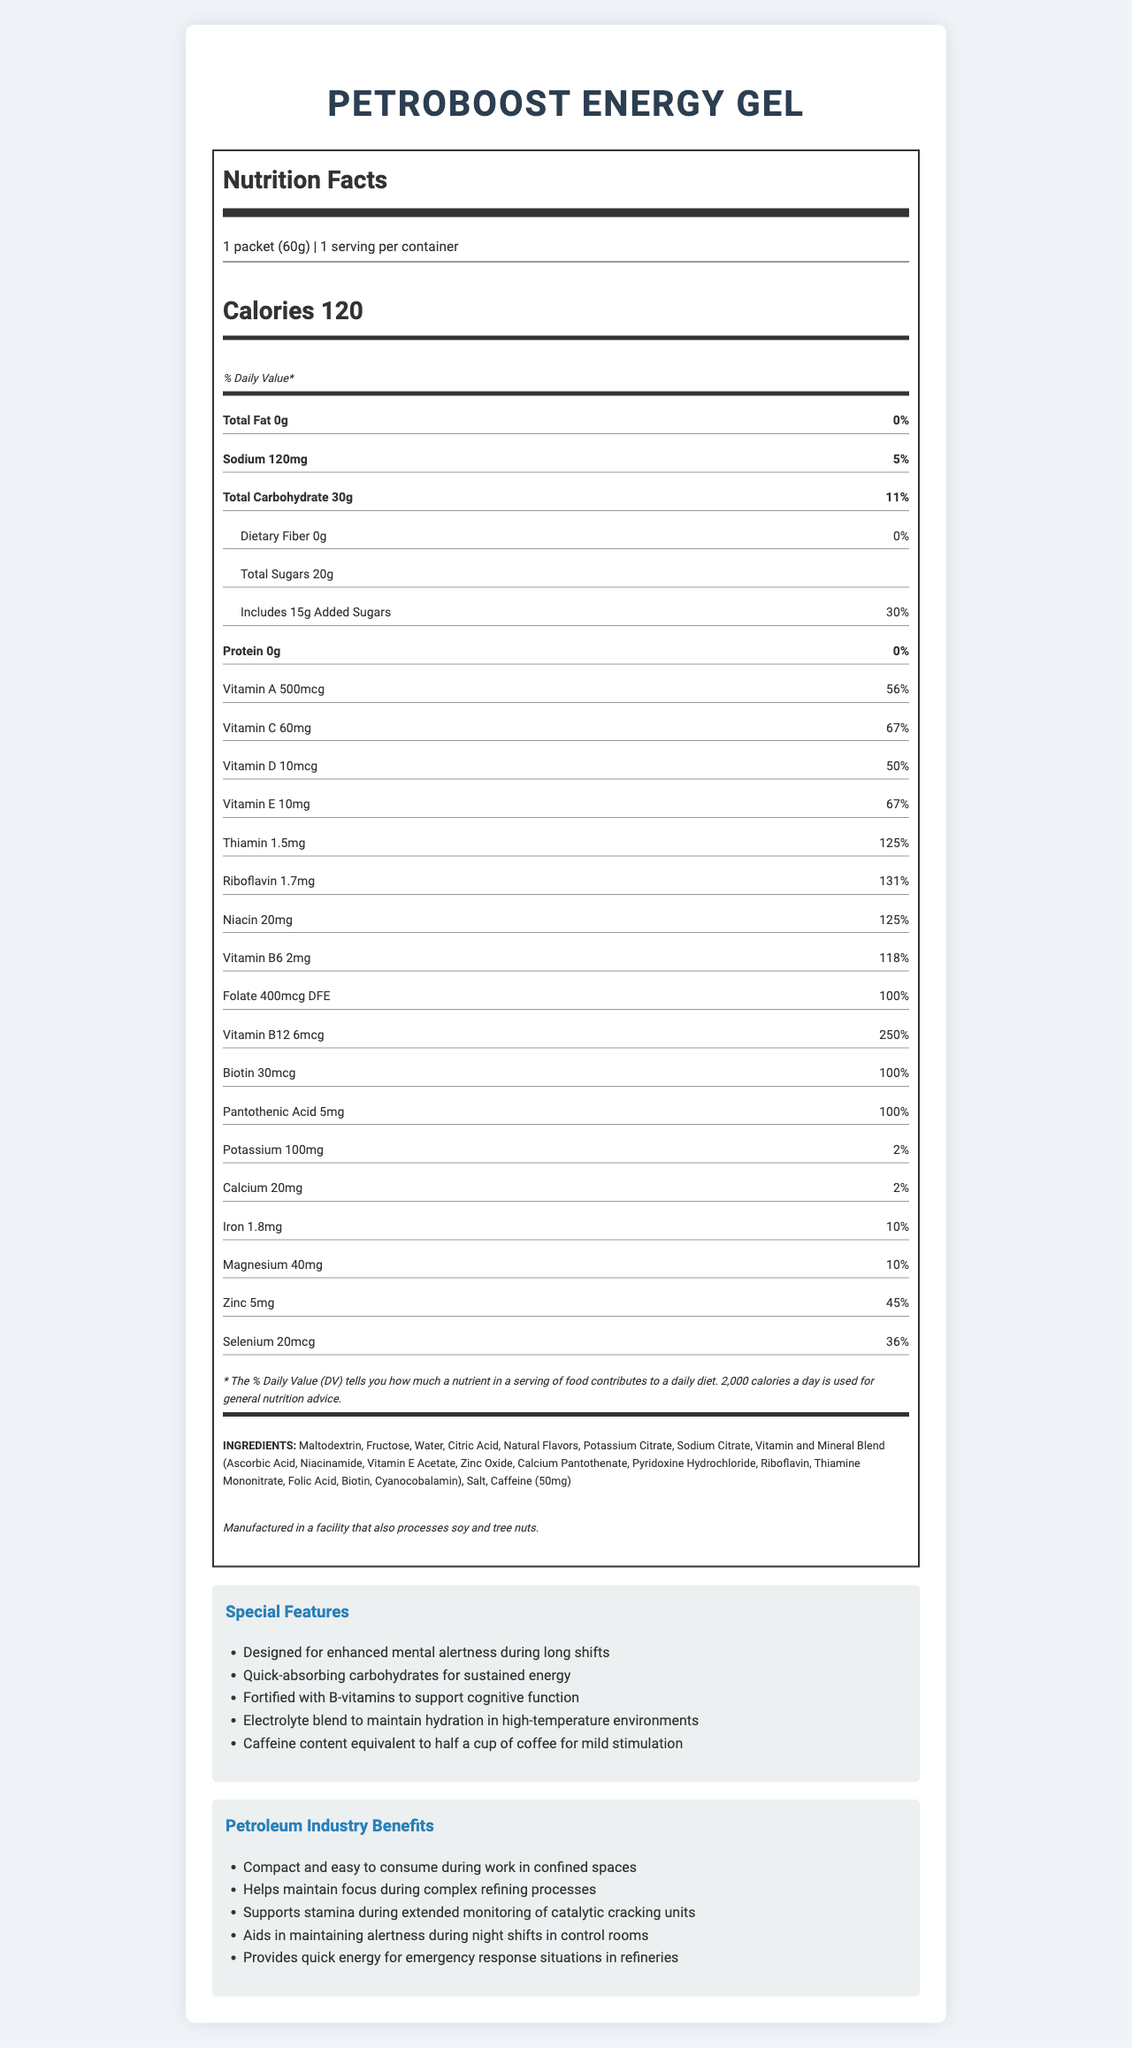what is the serving size of the PetroBoost Energy Gel? The serving size is listed at the top of the nutrition facts label as "1 packet (60g)".
Answer: 1 packet (60g) how many calories are in one serving of the PetroBoost Energy Gel? The number of calories per serving is prominently displayed in the nutrition facts section.
Answer: 120 how much sodium is in one packet? The sodium content is shown in the nutrition facts label with the amount being 120mg and a percent daily value of 5%.
Answer: 120mg which vitamin has the highest percent daily value in this product? A. Vitamin A B. Vitamin C C. Vitamin B12 D. Vitamin E Vitamin B12 has a percent daily value of 250%, which is higher than the percent daily values of other vitamins listed in the nutrition label.
Answer: C. Vitamin B12 is the PetroBoost Energy Gel a good source of protein? The protein content is 0g, which is 0% of the daily value, indicating it is not a source of protein.
Answer: No what is the caffeine content in PetroBoost Energy Gel? The caffeine content is mentioned in the ingredients list within the document.
Answer: 50mg list three special features of the PetroBoost Energy Gel. These features are detailed in the "Special Features" section.
Answer: Designed for enhanced mental alertness during long shifts, Quick-absorbing carbohydrates for sustained energy, Fortified with B-vitamins to support cognitive function which ingredient is listed first on the ingredients list? According to the ingredients section, Maltodextrin is listed first.
Answer: Maltodextrin is the PetroBoost Energy Gel manufactured in a facility that processes soy and tree nuts? The allergen information states that it is manufactured in a facility that also processes soy and tree nuts.
Answer: Yes name two benefits of the PetroBoost Energy Gel specific to the petroleum industry. These benefits are listed in the "Petroleum Industry Benefits" section.
Answer: Helps maintain focus during complex refining processes, Provides quick energy for emergency response situations in refineries is vitamin D content sufficient to meet 100% of the daily value? The vitamin D content is 10mcg, which is 50% of the daily value.
Answer: No what is the total amount of sugars, including added sugars, in one serving? The total sugars amount is listed as 20g, with 15g being added sugars.
Answer: 20g which nutrient has the lowest percent daily value in this product? A. Calcium B. Potassium C. Iron D. Magnesium Potassium has a percent daily value of 2%, which is the lowest among the listed options.
Answer: B. Potassium can the PetroBoost Energy Gel be used to maintain hydration in high-temperature environments? This is stated under the "Special Features" as one of its benefits.
Answer: Yes which benefit is related to night shifts in control rooms? This benefit is specifically mentioned in the "Petroleum Industry Benefits" section.
Answer: Aids in maintaining alertness during night shifts in control rooms describe the main purpose and key features of the PetroBoost Energy Gel as mentioned in the document. The description comes from the multiple sections, including "Special Features" and "Petroleum Industry Benefits".
Answer: The main purpose of the PetroBoost Energy Gel is to provide energy and mental alertness during long shifts in petrochemical facilities. Key features include quick-absorbing carbohydrates for sustained energy, B-vitamins for cognitive function, an electrolyte blend for hydration, and caffeine for mild stimulation. It is also designed to be compact and easy to consume in confined spaces. what are the differences between the amounts of total carbohydrate and dietary fiber? Dietary fiber is a component of total carbohydrate, and in this product, all carbohydrates come from other sources since the dietary fiber is 0g.
Answer: The total carbohydrate amount is 30g, while dietary fiber is 0g. how much thiamin does one packet of PetroBoost Energy Gel contain? The amount of thiamin is listed in the nutrition facts section as 1.5mg, with 125% of the daily value.
Answer: 1.5mg mention an aspect that is not detailed in the given document. The document does not provide any information about the flavor of the energy gel.
Answer: The flavor of the energy gel what are the allergens potentially present in the PetroBoost Energy Gel? The allergen information notes the facility processes soy and tree nuts, which implies potential allergens.
Answer: Soy and tree nuts does PetroBoost Energy Gel contain any fat? The total fat content is listed as 0g, indicating it contains no fat.
Answer: No 